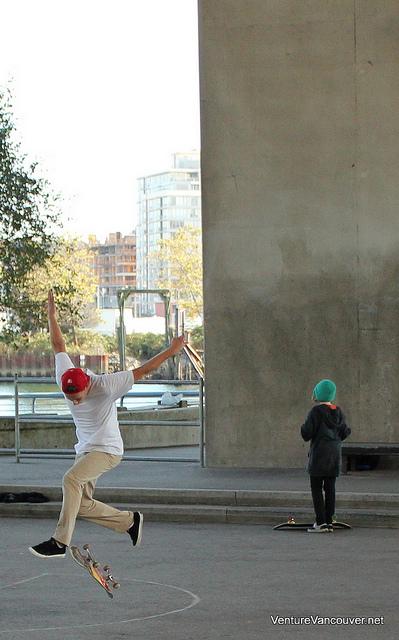Was this picture taken on a farm?
Quick response, please. No. Is the person with a green hat a male or female?
Quick response, please. Male. What is on the ground in front of the skateboarder?
Write a very short answer. Concrete. Is that a Half Pipe?
Give a very brief answer. No. What is the person in the Red Hat doing?
Short answer required. Skateboarding. 